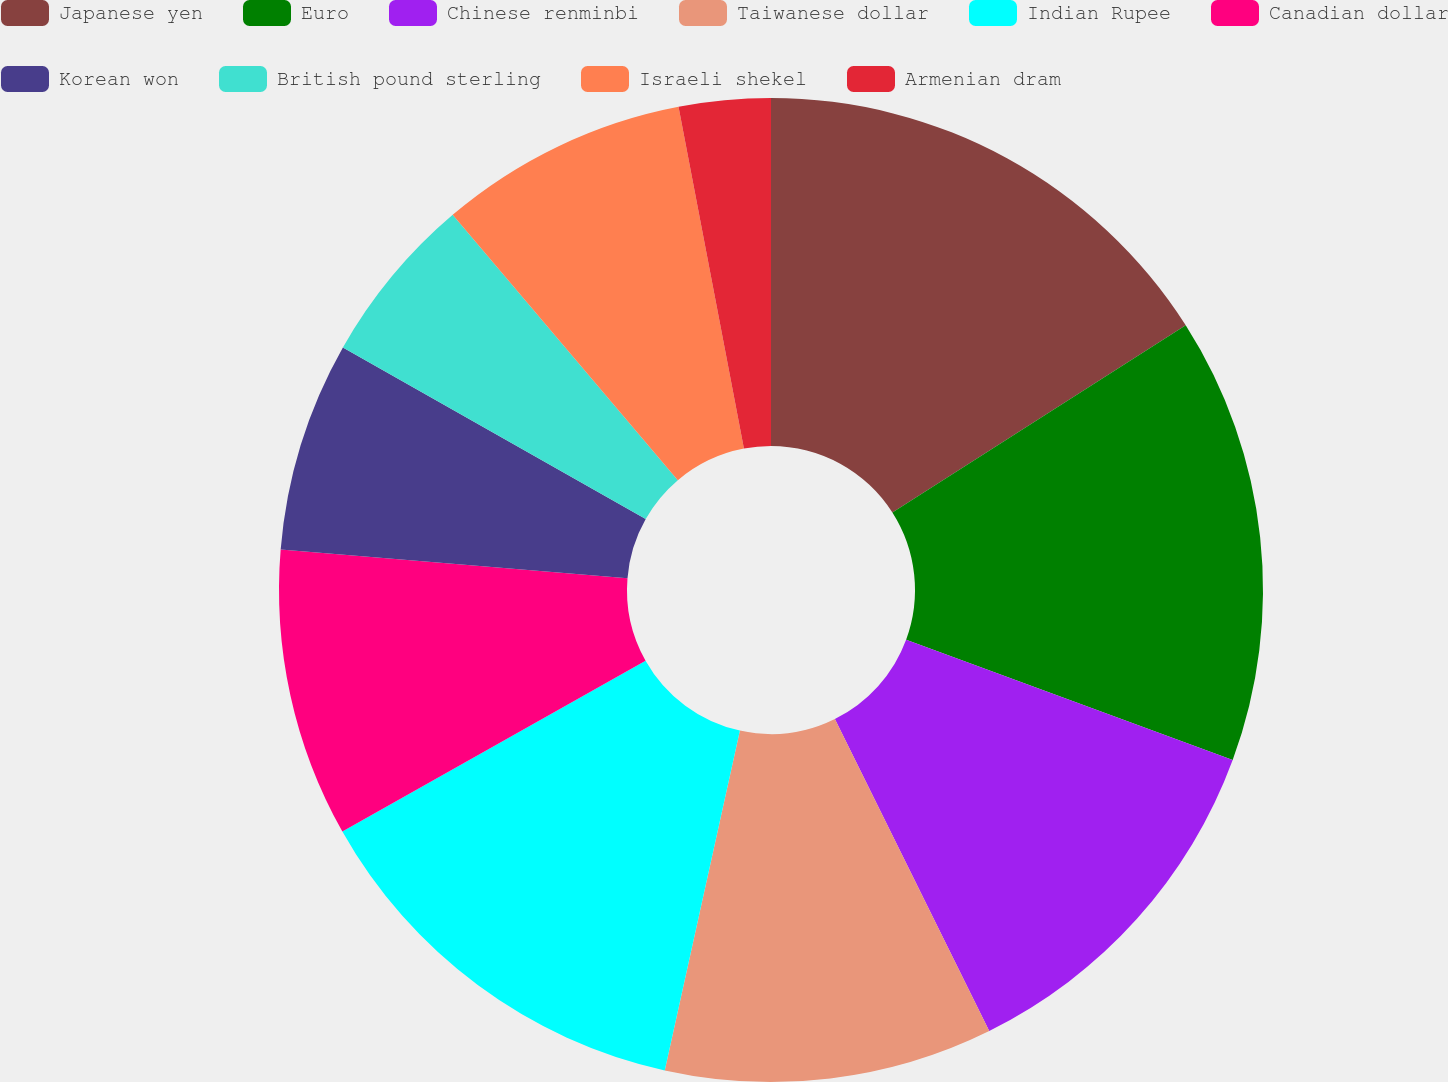<chart> <loc_0><loc_0><loc_500><loc_500><pie_chart><fcel>Japanese yen<fcel>Euro<fcel>Chinese renminbi<fcel>Taiwanese dollar<fcel>Indian Rupee<fcel>Canadian dollar<fcel>Korean won<fcel>British pound sterling<fcel>Israeli shekel<fcel>Armenian dram<nl><fcel>15.96%<fcel>14.66%<fcel>12.07%<fcel>10.78%<fcel>13.37%<fcel>9.48%<fcel>6.89%<fcel>5.6%<fcel>8.19%<fcel>3.01%<nl></chart> 